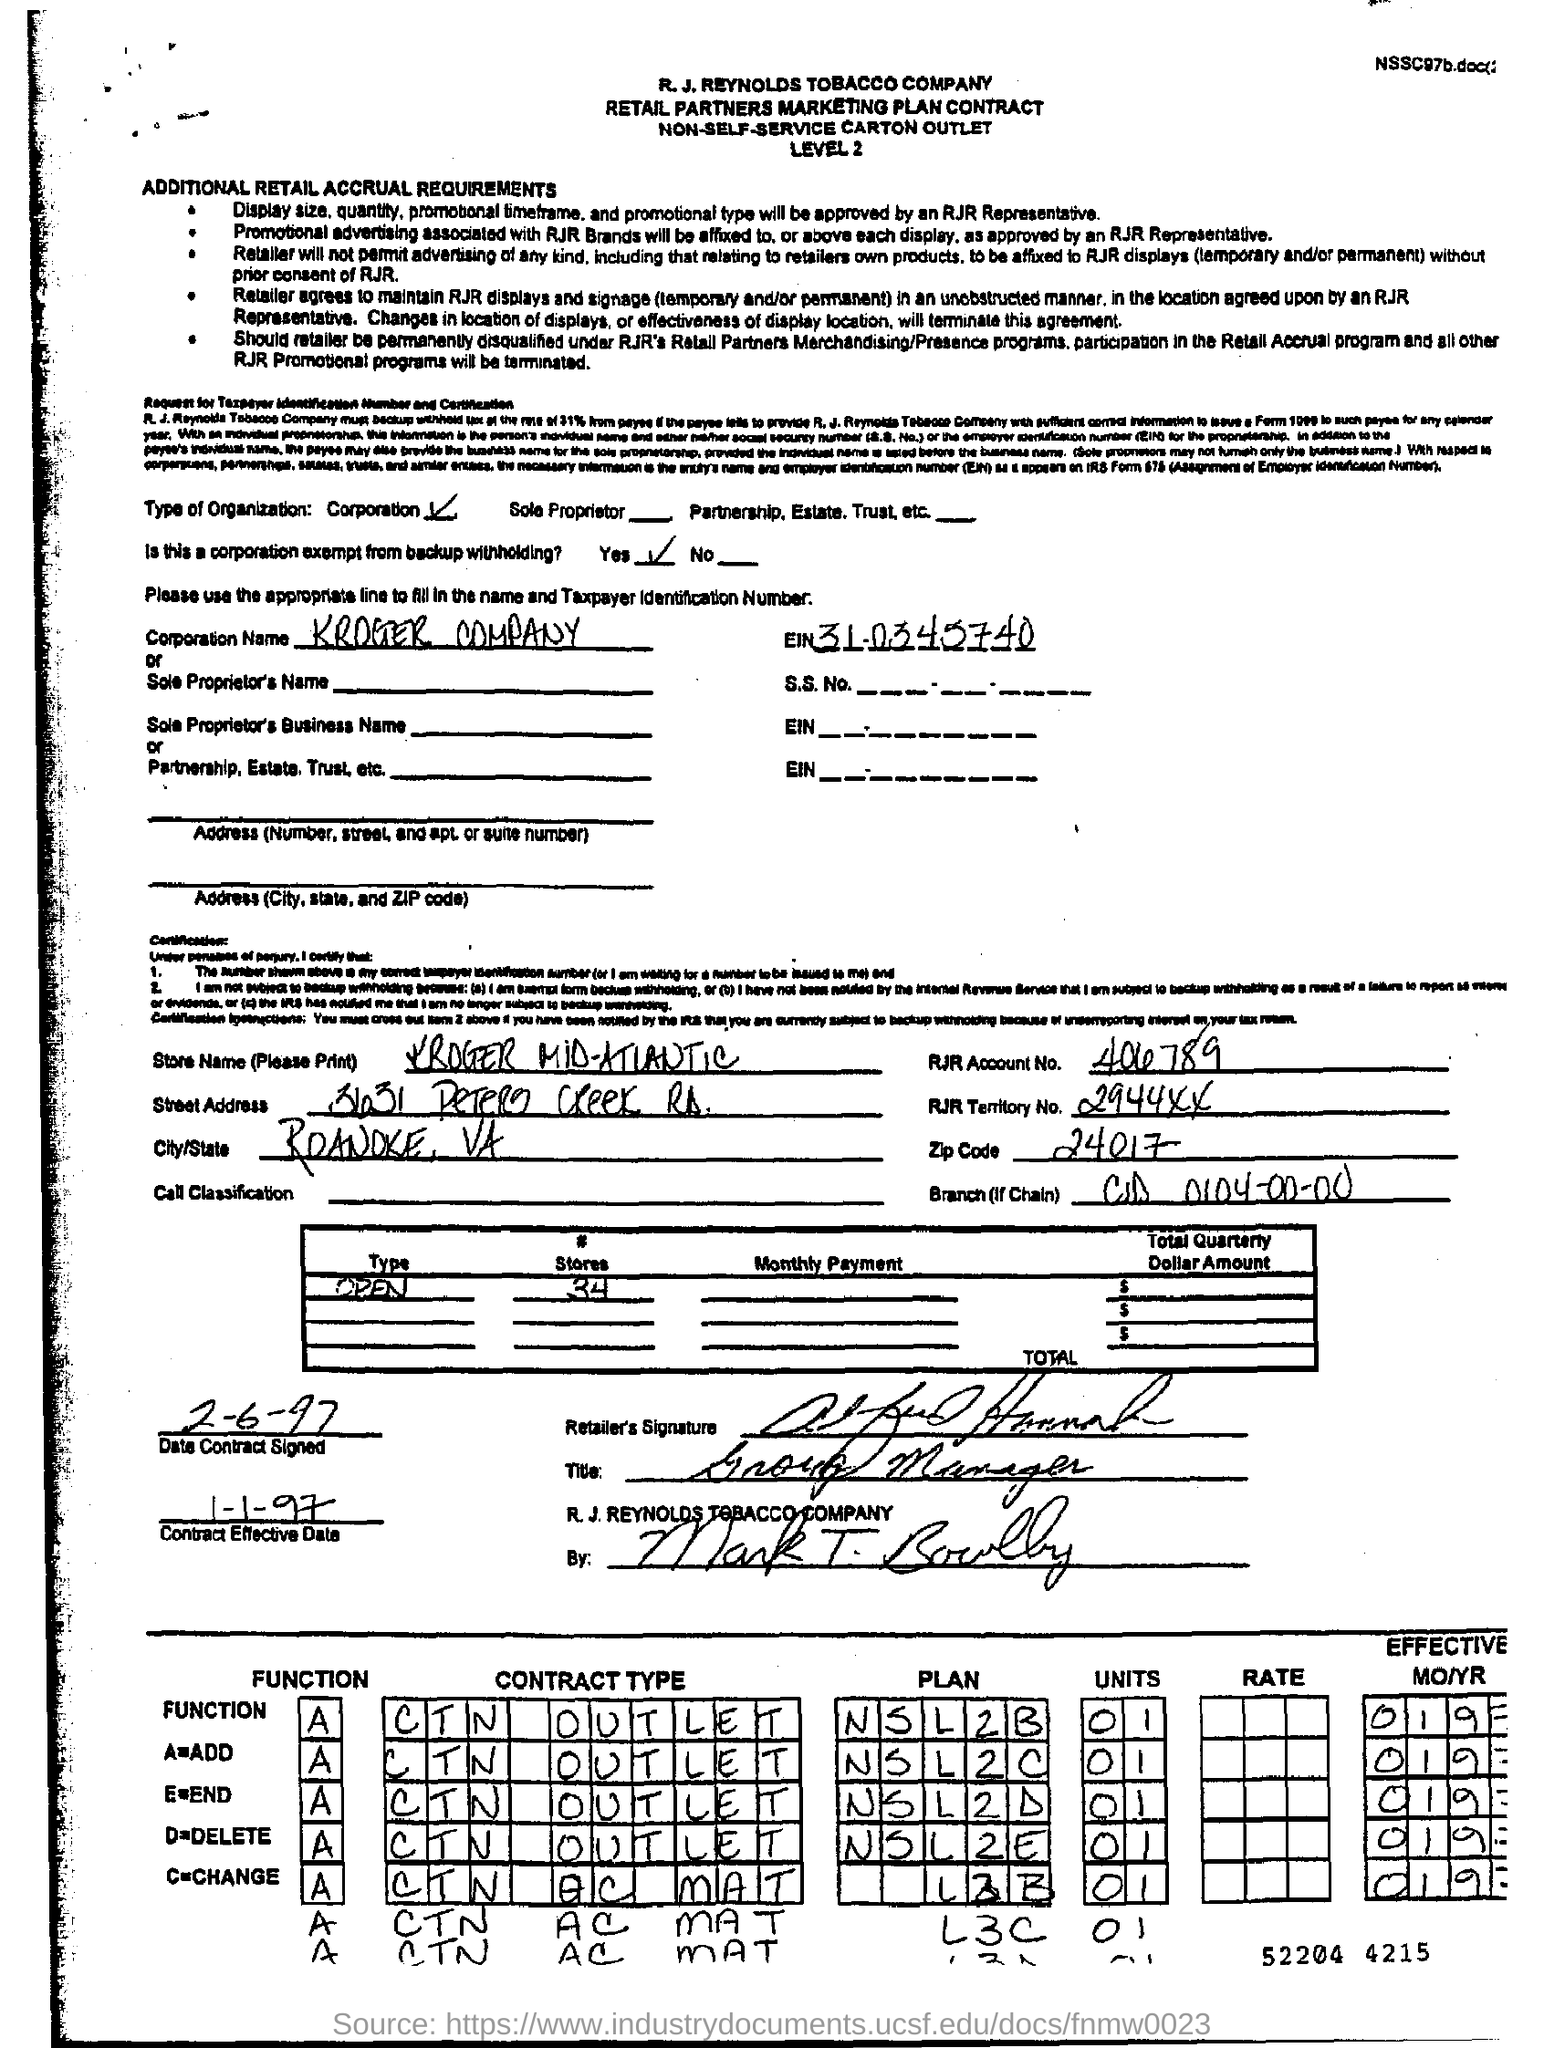What is the type of organisation ?
Give a very brief answer. Corporation. Is this a corporation exempt from backup withholding ?
Your response must be concise. Yes. How many #stores are there ?
Offer a very short reply. 34. What is the zipcode ?
Your answer should be compact. 24017. What is the function a=?
Provide a succinct answer. Add. What is the rjr account no.?
Make the answer very short. 406789. Mention the contract effective date ?
Your response must be concise. 1-1-97. When is the contract signed ?
Give a very brief answer. 2-6-97. 